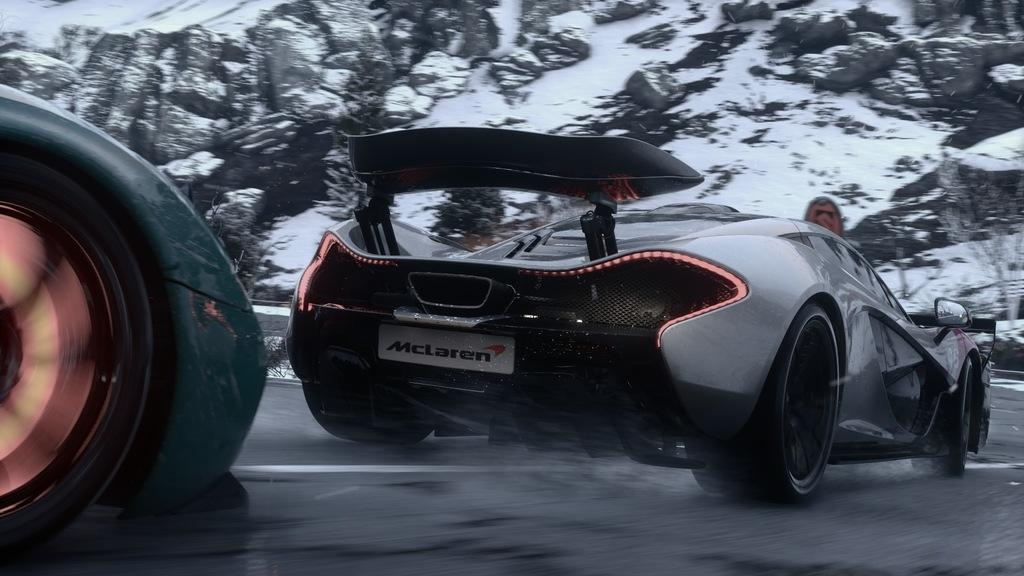What is happening on the road in the image? Vehicles are moving on the road in the image. What can be seen in the background of the image? There are stones with snow, a sign board, and plants in the background of the image. How many jellyfish are swimming in the image? There are no jellyfish present in the image. What type of party is being held in the image? There is no party depicted in the image. 